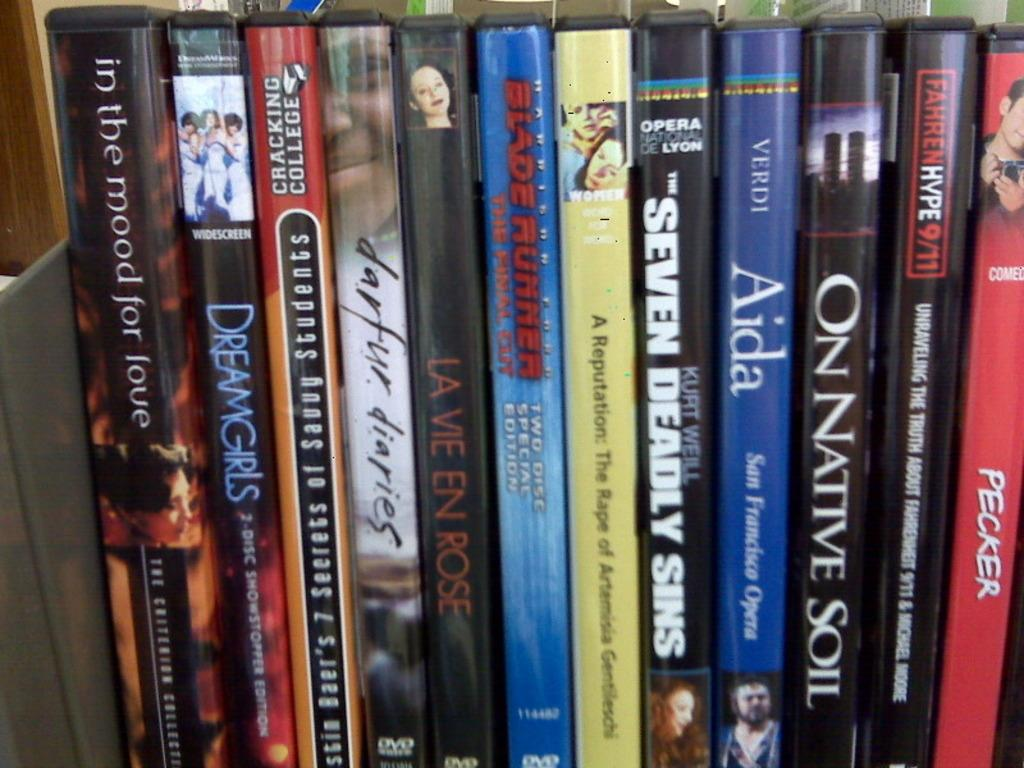<image>
Provide a brief description of the given image. A close up view of movies with the names of "Aida" and "One Native Soil" 